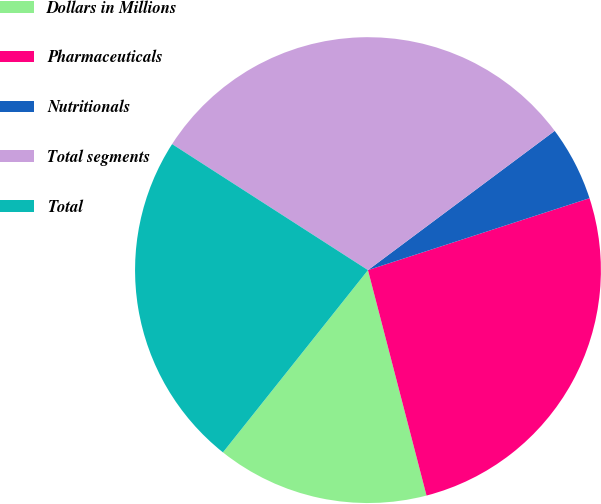Convert chart. <chart><loc_0><loc_0><loc_500><loc_500><pie_chart><fcel>Dollars in Millions<fcel>Pharmaceuticals<fcel>Nutritionals<fcel>Total segments<fcel>Total<nl><fcel>14.74%<fcel>25.95%<fcel>5.2%<fcel>30.7%<fcel>23.4%<nl></chart> 